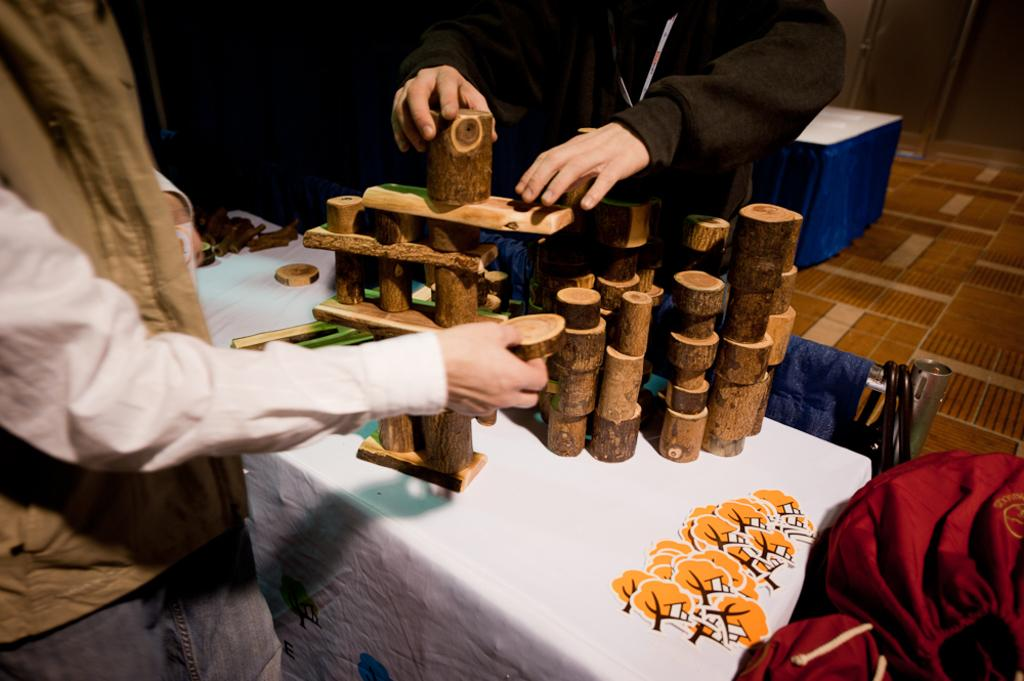How many people are in the image? There are two persons in the image. What are the persons doing in the image? The persons are arranging wooden blocks. How are the wooden blocks being placed? The wooden blocks are being placed one above the other. What is the surface on which the wooden blocks are being arranged? There is a table in the image. What type of leaf can be seen on the table in the image? There is no leaf present on the table in the image. How many things are being pointed at in the image? There is no pointing activity depicted in the image. 